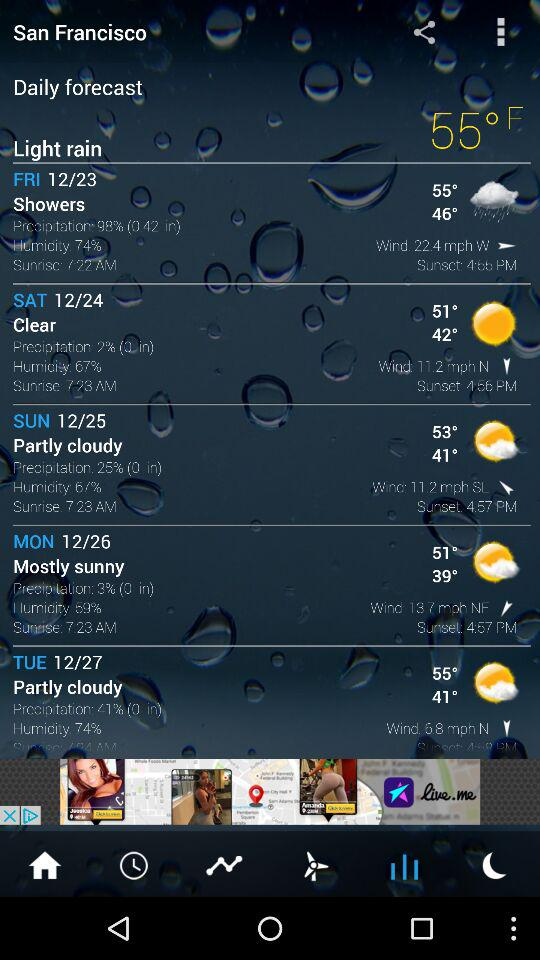What's the forecast for Tuesday? The weather is partly cloudy. 